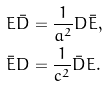Convert formula to latex. <formula><loc_0><loc_0><loc_500><loc_500>E \bar { D } & = \frac { 1 } { a ^ { 2 } } D \bar { E } , \\ \bar { E } D & = \frac { 1 } { c ^ { 2 } } \bar { D } E . \\</formula> 